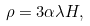<formula> <loc_0><loc_0><loc_500><loc_500>\rho = 3 \alpha \lambda H ,</formula> 